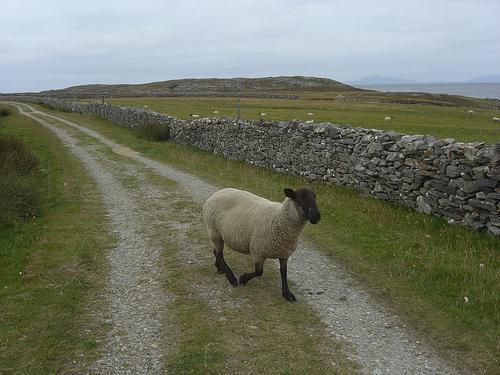How many sheep are there?
Give a very brief answer. 1. How many black sheeps are there?
Give a very brief answer. 0. 